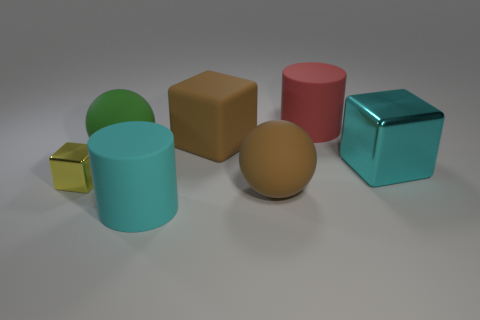Add 1 big blue metal blocks. How many objects exist? 8 Subtract all cylinders. How many objects are left? 5 Add 6 brown rubber cubes. How many brown rubber cubes are left? 7 Add 5 metal cubes. How many metal cubes exist? 7 Subtract 0 purple cubes. How many objects are left? 7 Subtract all balls. Subtract all large cyan matte things. How many objects are left? 4 